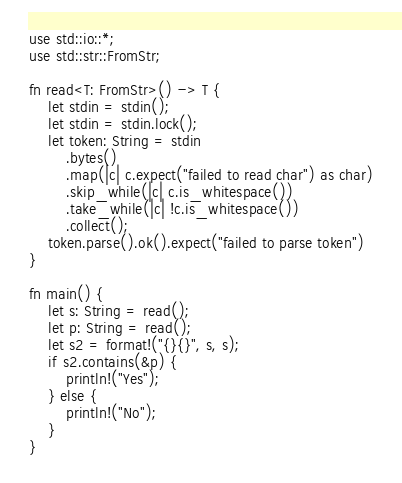<code> <loc_0><loc_0><loc_500><loc_500><_Rust_>use std::io::*;
use std::str::FromStr;

fn read<T: FromStr>() -> T {
    let stdin = stdin();
    let stdin = stdin.lock();
    let token: String = stdin
        .bytes()
        .map(|c| c.expect("failed to read char") as char)
        .skip_while(|c| c.is_whitespace())
        .take_while(|c| !c.is_whitespace())
        .collect();
    token.parse().ok().expect("failed to parse token")
}

fn main() {
    let s: String = read();
    let p: String = read();
    let s2 = format!("{}{}", s, s);
    if s2.contains(&p) {
        println!("Yes");
    } else {
        println!("No");
    }
}
</code> 